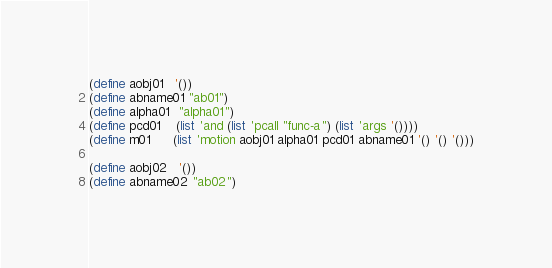Convert code to text. <code><loc_0><loc_0><loc_500><loc_500><_Scheme_>(define aobj01   '())
(define abname01 "ab01")
(define alpha01  "alpha01")
(define pcd01    (list 'and (list 'pcall "func-a") (list 'args '())))
(define m01      (list 'motion aobj01 alpha01 pcd01 abname01 '() '() '()))

(define aobj02   '())
(define abname02 "ab02")</code> 